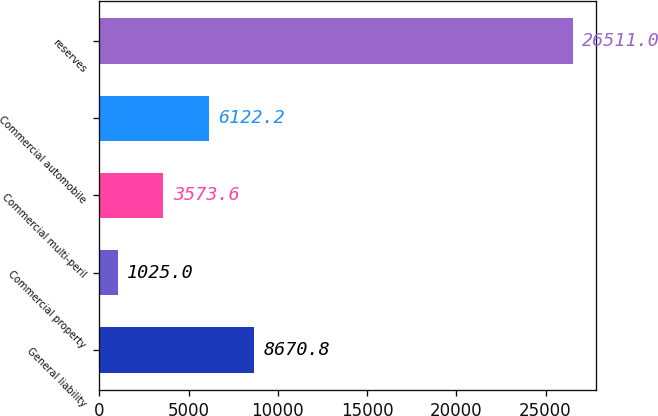Convert chart. <chart><loc_0><loc_0><loc_500><loc_500><bar_chart><fcel>General liability<fcel>Commercial property<fcel>Commercial multi-peril<fcel>Commercial automobile<fcel>reserves<nl><fcel>8670.8<fcel>1025<fcel>3573.6<fcel>6122.2<fcel>26511<nl></chart> 